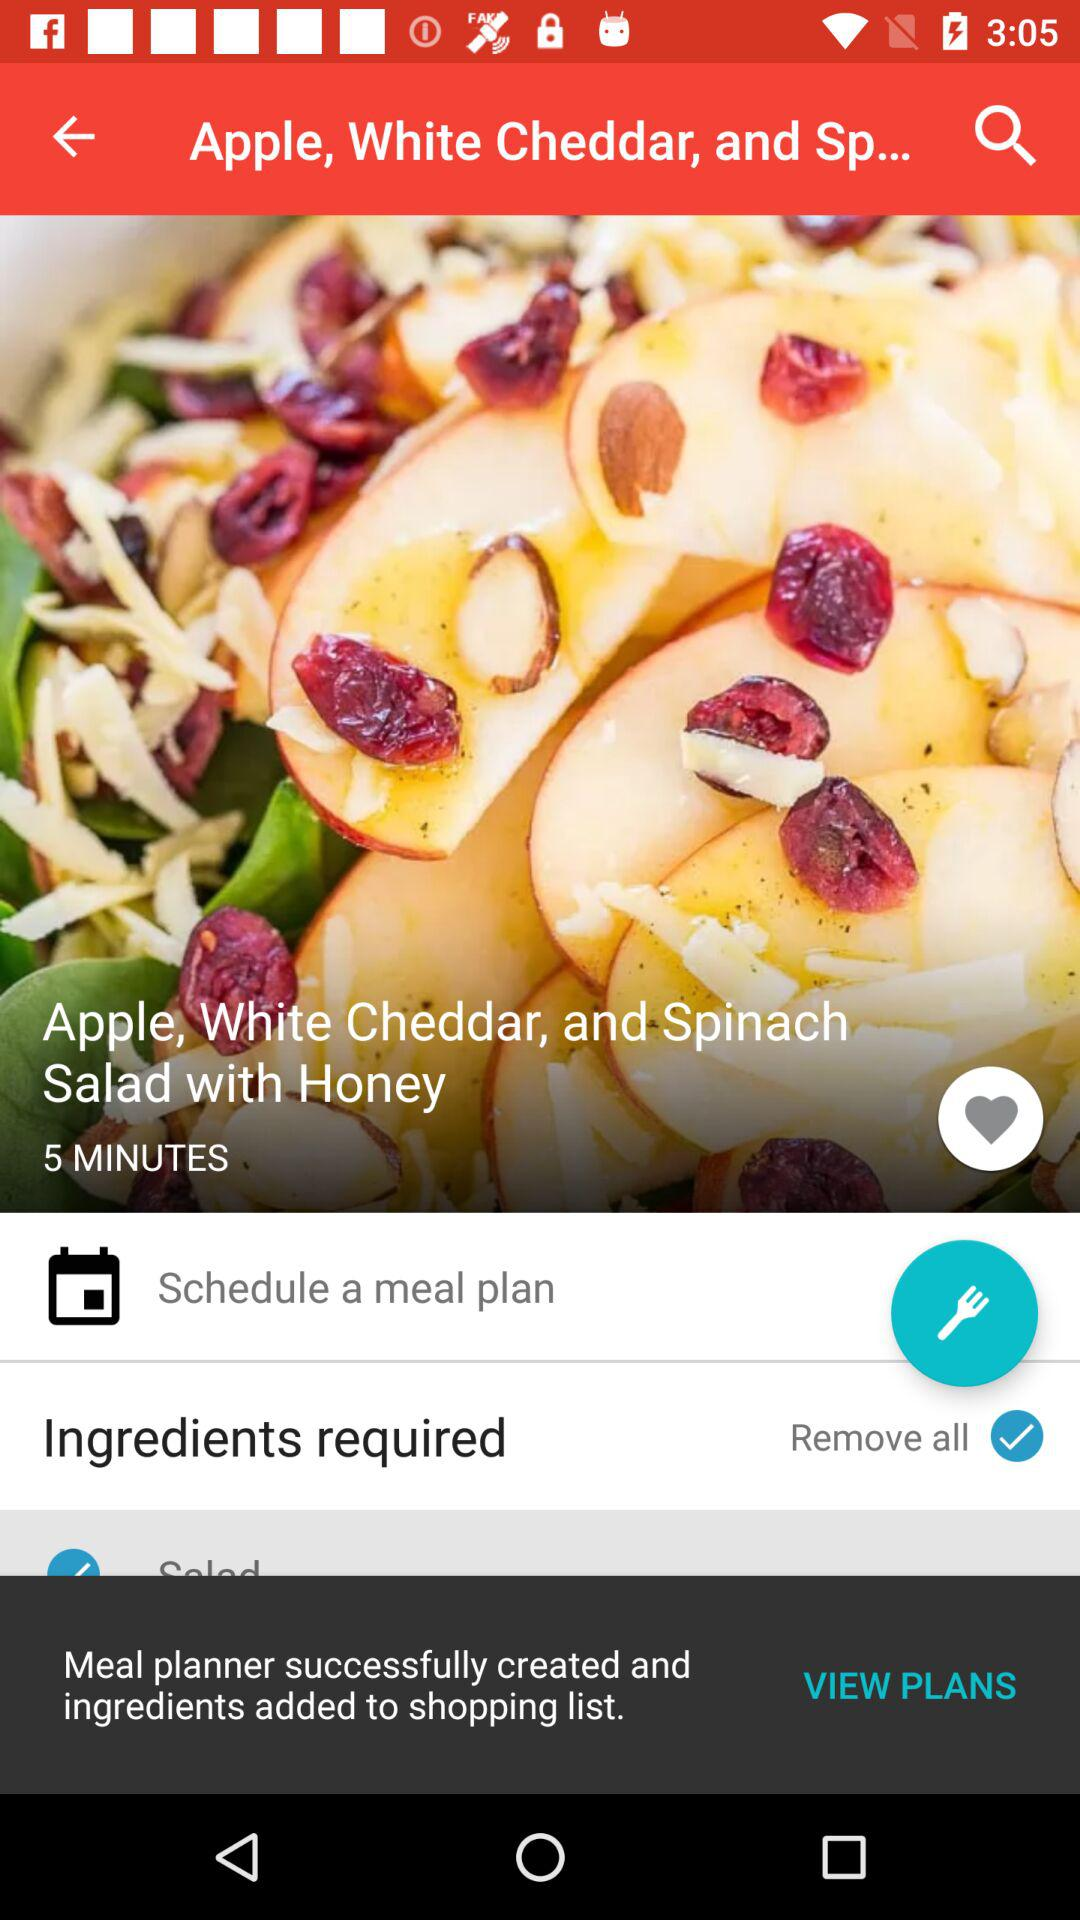How much white cheddar does the recipe require?
When the provided information is insufficient, respond with <no answer>. <no answer> 